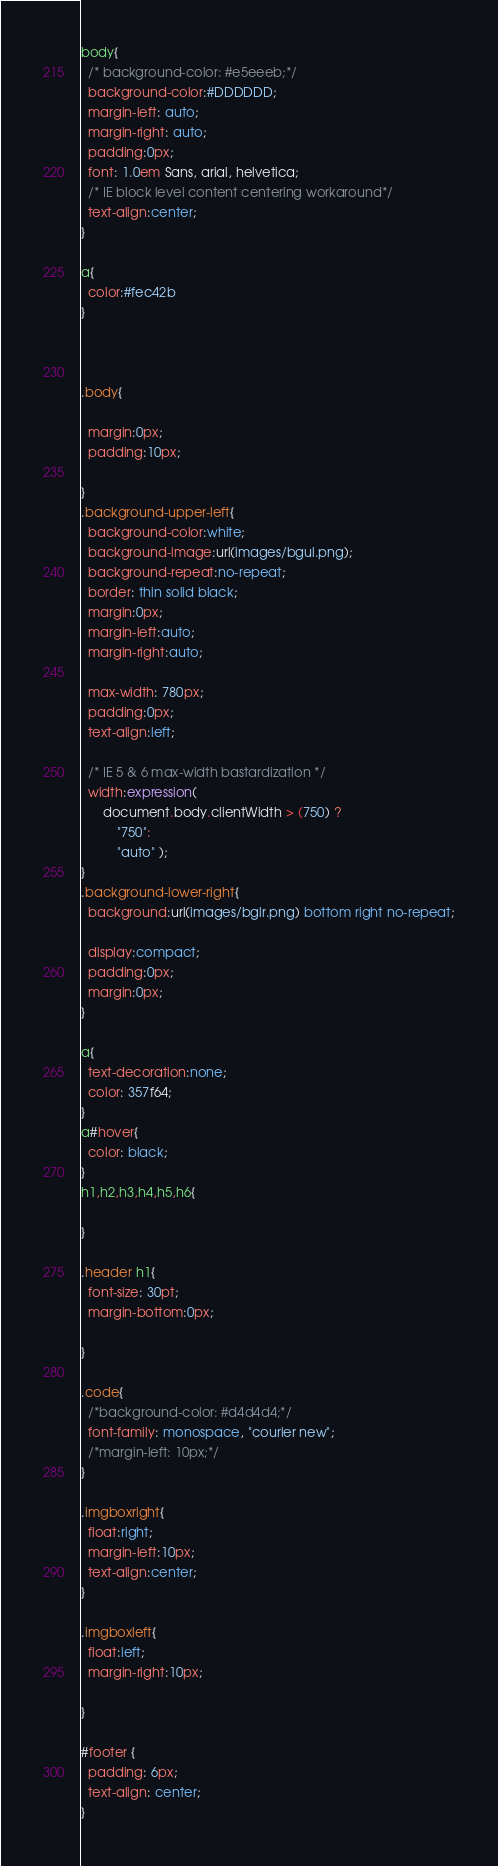<code> <loc_0><loc_0><loc_500><loc_500><_CSS_>body{
  /* background-color: #e5eeeb;*/
  background-color:#DDDDDD;
  margin-left: auto;
  margin-right: auto;
  padding:0px;
  font: 1.0em Sans, arial, helvetica;
  /* IE block level content centering workaround*/
  text-align:center;
}

a{
  color:#fec42b
}



.body{

  margin:0px;
  padding:10px;

}
.background-upper-left{
  background-color:white;
  background-image:url(images/bgul.png);
  background-repeat:no-repeat;
  border: thin solid black;
  margin:0px;
  margin-left:auto;
  margin-right:auto;

  max-width: 780px;
  padding:0px;
  text-align:left;

  /* IE 5 & 6 max-width bastardization */
  width:expression(
      document.body.clientWidth > (750) ?
          "750":
          "auto" );
}
.background-lower-right{
  background:url(images/bglr.png) bottom right no-repeat;

  display:compact;
  padding:0px;
  margin:0px;
}

a{
  text-decoration:none;
  color: 357f64;
}
a#hover{
  color: black;
}
h1,h2,h3,h4,h5,h6{

}

.header h1{
  font-size: 30pt;
  margin-bottom:0px;

}

.code{
  /*background-color: #d4d4d4;*/
  font-family: monospace, "courier new";
  /*margin-left: 10px;*/
}

.imgboxright{
  float:right;
  margin-left:10px;
  text-align:center;
}

.imgboxleft{
  float:left;
  margin-right:10px;

}

#footer {
  padding: 6px;
  text-align: center;
}
</code> 